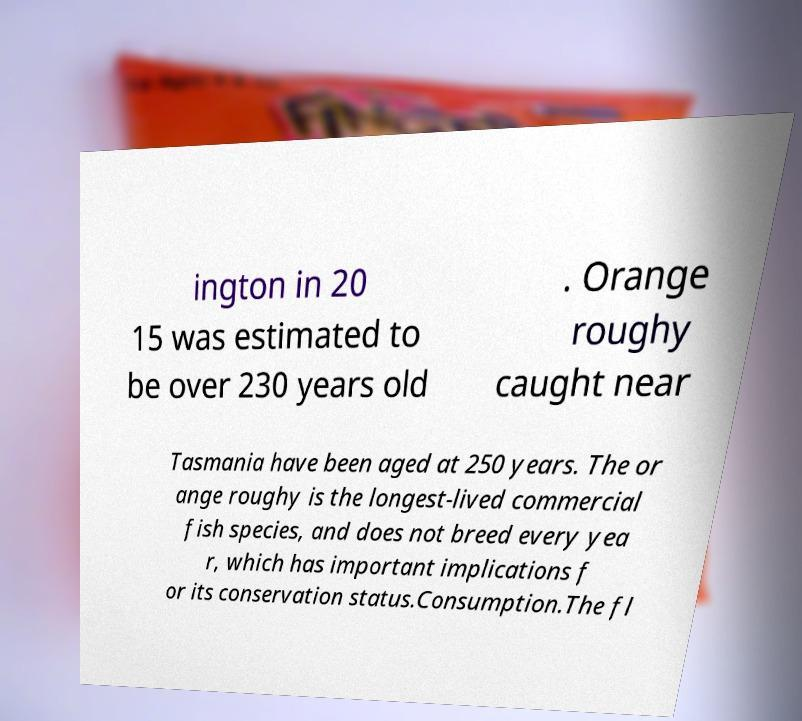Please identify and transcribe the text found in this image. ington in 20 15 was estimated to be over 230 years old . Orange roughy caught near Tasmania have been aged at 250 years. The or ange roughy is the longest-lived commercial fish species, and does not breed every yea r, which has important implications f or its conservation status.Consumption.The fl 